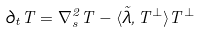<formula> <loc_0><loc_0><loc_500><loc_500>\partial _ { t } T = \nabla _ { s } ^ { 2 } T - \langle \vec { \lambda } , T ^ { \perp } \rangle T ^ { \perp }</formula> 